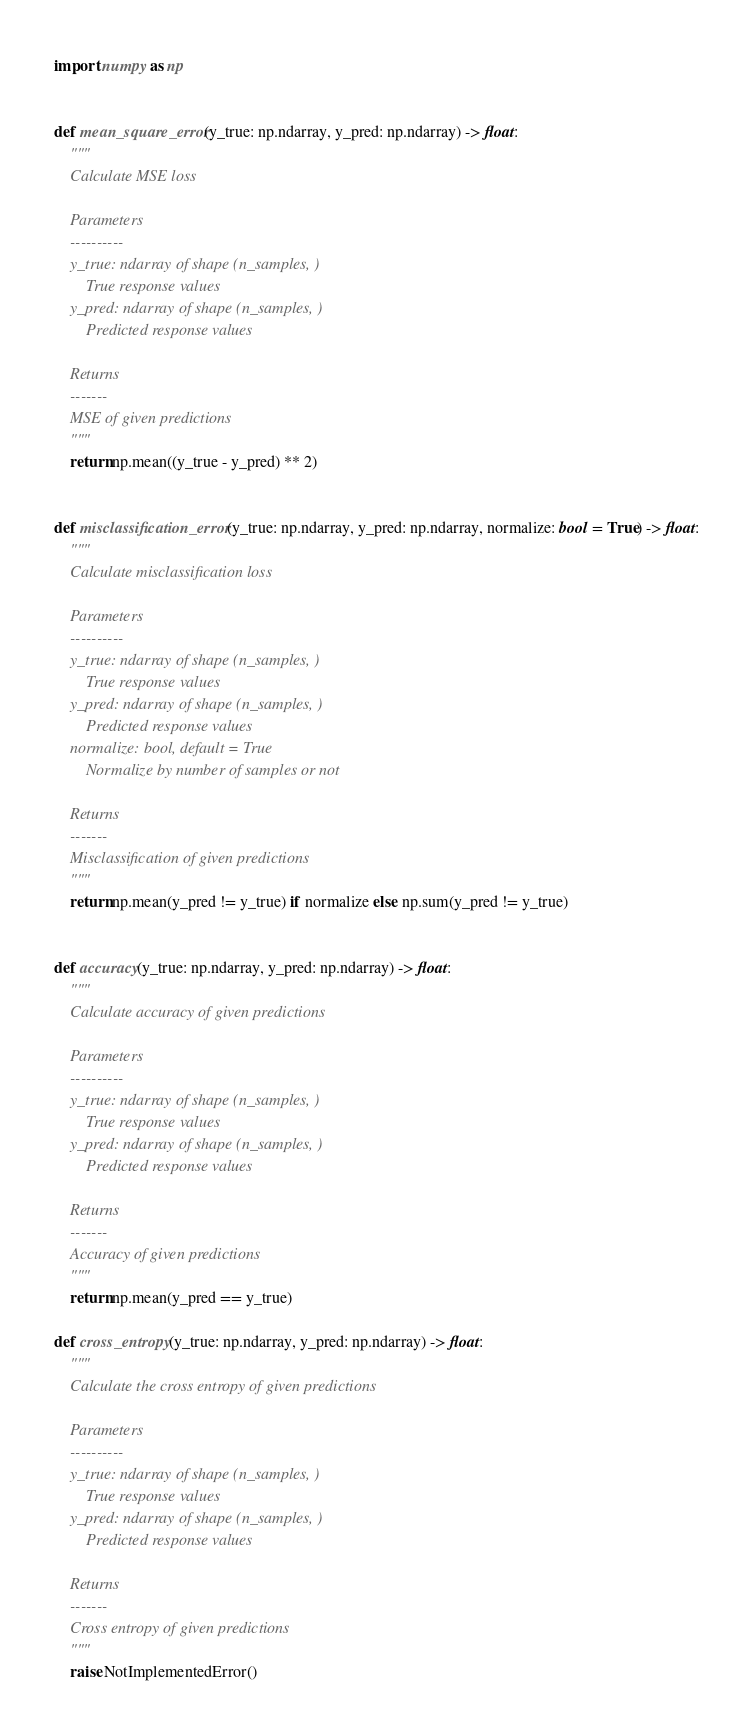Convert code to text. <code><loc_0><loc_0><loc_500><loc_500><_Python_>import numpy as np


def mean_square_error(y_true: np.ndarray, y_pred: np.ndarray) -> float:
    """
    Calculate MSE loss

    Parameters
    ----------
    y_true: ndarray of shape (n_samples, )
        True response values
    y_pred: ndarray of shape (n_samples, )
        Predicted response values

    Returns
    -------
    MSE of given predictions
    """
    return np.mean((y_true - y_pred) ** 2)


def misclassification_error(y_true: np.ndarray, y_pred: np.ndarray, normalize: bool = True) -> float:
    """
    Calculate misclassification loss

    Parameters
    ----------
    y_true: ndarray of shape (n_samples, )
        True response values
    y_pred: ndarray of shape (n_samples, )
        Predicted response values
    normalize: bool, default = True
        Normalize by number of samples or not

    Returns
    -------
    Misclassification of given predictions
    """
    return np.mean(y_pred != y_true) if normalize else np.sum(y_pred != y_true)


def accuracy(y_true: np.ndarray, y_pred: np.ndarray) -> float:
    """
    Calculate accuracy of given predictions

    Parameters
    ----------
    y_true: ndarray of shape (n_samples, )
        True response values
    y_pred: ndarray of shape (n_samples, )
        Predicted response values

    Returns
    -------
    Accuracy of given predictions
    """
    return np.mean(y_pred == y_true)

def cross_entropy(y_true: np.ndarray, y_pred: np.ndarray) -> float:
    """
    Calculate the cross entropy of given predictions

    Parameters
    ----------
    y_true: ndarray of shape (n_samples, )
        True response values
    y_pred: ndarray of shape (n_samples, )
        Predicted response values

    Returns
    -------
    Cross entropy of given predictions
    """
    raise NotImplementedError()
</code> 